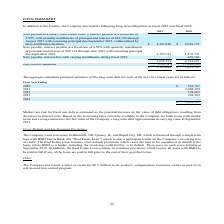From Amcon Distributing's financial document, What are the respective values of the company's net long term debt in 2018 and 2019? The document shows two values: $3,658,391 and $3,125,644. From the document: "$ 3,125,644 $ 3,658,391 varying installments during fiscal 2019 — 629,746 3,658,391 4,754,697..." Also, What are the respective values of the company's current maturities in 2018 and 2019? The document shows two values: 1,096,306 and 532,747. From the document: "Less current maturities (532,747) (1,096,306) Less current maturities (532,747) (1,096,306)..." Also, What are the respective values of the company's interest-free note payable in 2018 and 2019? The document shows two values: 629,746 and 0. From the document: "ee with varying installments during fiscal 2019 — 629,746 3,658,391 4,754,697 ee with varying installments during fiscal 2019 — 629,746 3,658,391 4,75..." Also, can you calculate: What is the percentage change in the company's net long-term debt between 2018 and 2019? To answer this question, I need to perform calculations using the financial data. The calculation is: (3,125,644 - 3,658,391)/3,658,391 , which equals -14.56 (percentage). This is based on the information: "varying installments during fiscal 2019 — 629,746 3,658,391 4,754,697 $ 3,125,644 $ 3,658,391..." The key data points involved are: 3,125,644, 3,658,391. Also, can you calculate: What is the percentage change in the company's interest-free note payable between 2018 and 2019? To answer this question, I need to perform calculations using the financial data. The calculation is: (0 - 629,746)/629,746 , which equals -100 (percentage). This is based on the information: "ee with varying installments during fiscal 2019 — 629,746 3,658,391 4,754,697 ee with varying installments during fiscal 2019 — 629,746 3,658,391 4,754,697..." The key data points involved are: 629,746. Also, can you calculate: What is the difference in the company's current maturities between 2018 and 2019? Based on the calculation: -532,747 - (1,096,306) , the result is 563559. This is based on the information: "Less current maturities (532,747) (1,096,306) Less current maturities (532,747) (1,096,306)..." The key data points involved are: 1,096,306, 532,747. 